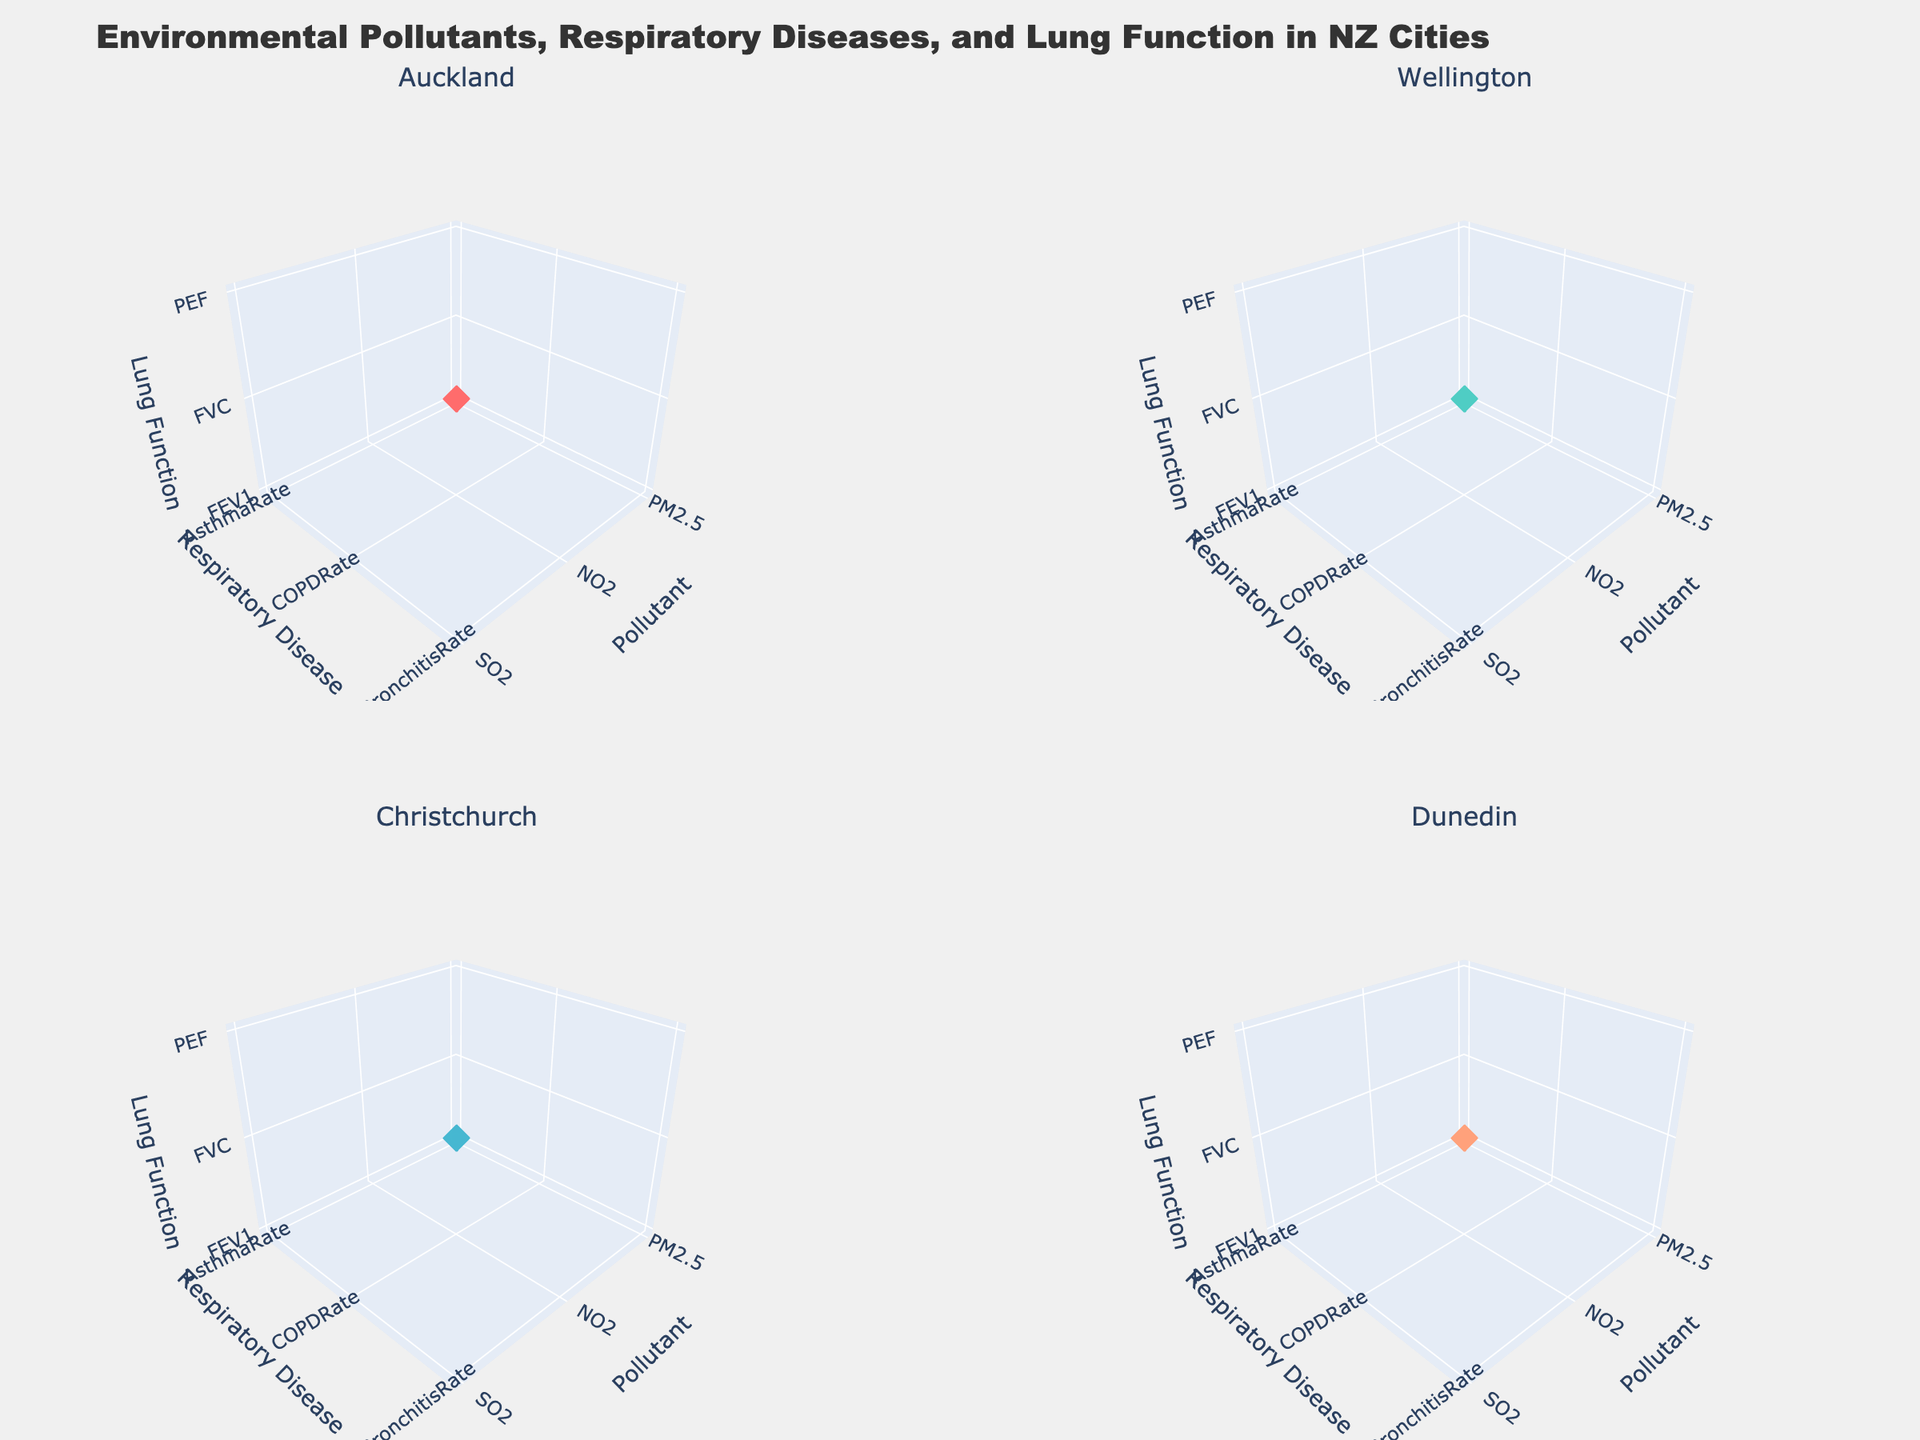What is the title of the figure? The title is located prominently at the top of the figure.
Answer: "Environmental Pollutants, Respiratory Diseases, and Lung Function in NZ Cities" What are the labels of the axes in the subplot for Wellington? Each subplot has three axes labeled: 'Pollutant' (x-axis), 'Respiratory Disease' (y-axis), and 'Lung Function' (z-axis).
Answer: 'Pollutant', 'Respiratory Disease', 'Lung Function' How many different pollutants are represented in each subplot? There are three distinct pollutants represented: PM2.5, NO2, and SO2.
Answer: 3 Which city has the highest range of variation in lung function metrics (z-axis)? By examining the z-axis range across all subplots, Christchurch has the highest variation in lung function metrics.
Answer: Christchurch In which city do you see the highest incidence of the respiratory disease correlated with NO2? Look at the y-axis value associated with NO2 across the cities; Christchurch has the highest y-axis (Respiratory Disease) value for NO2.
Answer: Christchurch Which city shows the lowest asthma rate (linked to PM2.5 concentration)? In the Auckland subplot, the data point for AsthmaRate with PM2.5 with the lowest y-axis value needs to be identified.
Answer: Dunedin What is the pollutant and its corresponding lung function value that has the lowest value in Wellington? Observing the lowest z-axis (Lung Function) value in Wellington's subplot, match it with the corresponding pollutant.
Answer: SO2, 86 Which pollutant in Christchurch correlates with the highest respiratory disease rate? Identify the highest y-axis value in the subplot for Christchurch and find the corresponding pollutant.
Answer: NO2 What is the overall shape of the markers used in these plots? The markers in the plots are described as 'diamond' shaped.
Answer: Diamond What color represents the data points for Auckland? Auckland's data points are red, consistent with the color assigned in the provided script.
Answer: Red 